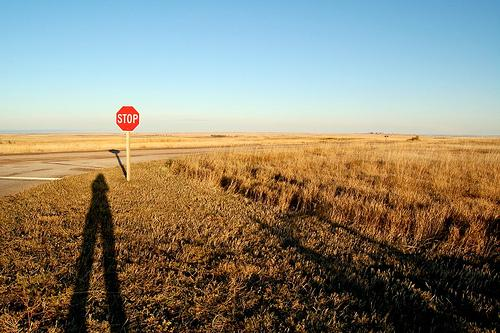Question: how would a driver obey the sign shown in the photo?
Choices:
A. By yielding.
B. By merging.
C. By being cautious.
D. By stopping.
Answer with the letter. Answer: D Question: what does the sign in the photo read?
Choices:
A. Yield.
B. Stop.
C. Merge.
D. Caution.
Answer with the letter. Answer: B Question: what is the background color of the stop sign?
Choices:
A. Red.
B. White.
C. Green.
D. Orange.
Answer with the letter. Answer: A Question: what does the road appear to have been paved with?
Choices:
A. Asphalt.
B. Concrete.
C. Brick.
D. Shell.
Answer with the letter. Answer: A Question: who is seen in this photo?
Choices:
A. Man.
B. Woman.
C. No One.
D. Child.
Answer with the letter. Answer: C 